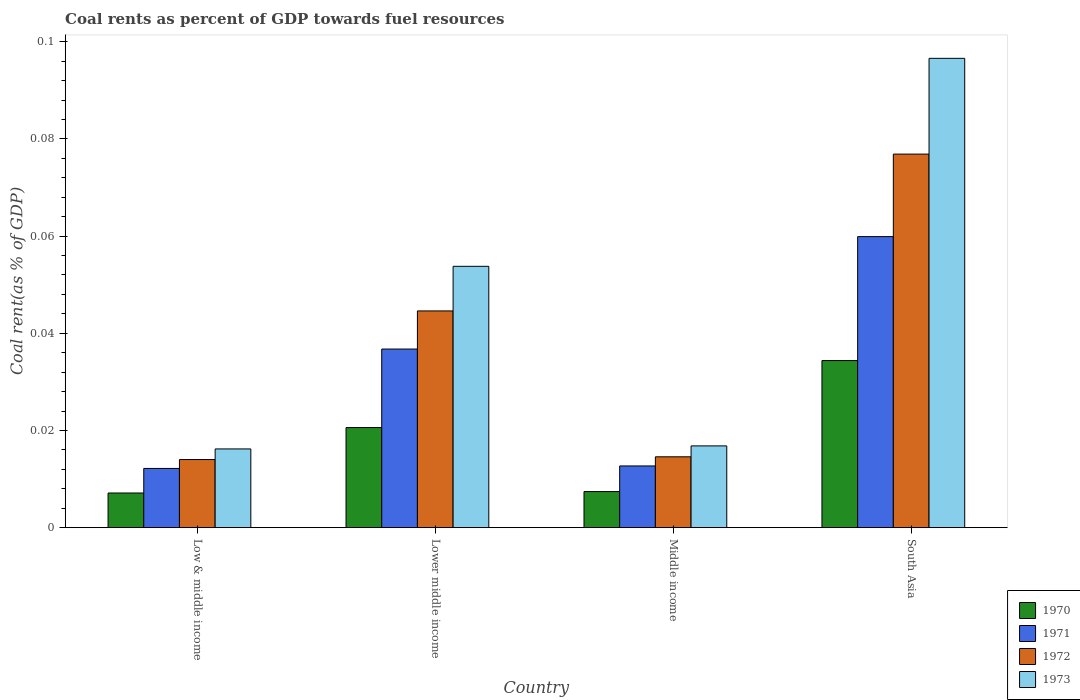What is the coal rent in 1971 in South Asia?
Provide a succinct answer. 0.06. Across all countries, what is the maximum coal rent in 1973?
Give a very brief answer. 0.1. Across all countries, what is the minimum coal rent in 1971?
Offer a terse response. 0.01. In which country was the coal rent in 1971 minimum?
Ensure brevity in your answer.  Low & middle income. What is the total coal rent in 1972 in the graph?
Your response must be concise. 0.15. What is the difference between the coal rent in 1972 in Low & middle income and that in South Asia?
Your response must be concise. -0.06. What is the difference between the coal rent in 1971 in South Asia and the coal rent in 1973 in Middle income?
Offer a terse response. 0.04. What is the average coal rent in 1973 per country?
Your answer should be compact. 0.05. What is the difference between the coal rent of/in 1972 and coal rent of/in 1970 in Middle income?
Provide a succinct answer. 0.01. In how many countries, is the coal rent in 1971 greater than 0.06 %?
Your answer should be very brief. 0. What is the ratio of the coal rent in 1972 in Lower middle income to that in South Asia?
Your response must be concise. 0.58. Is the coal rent in 1970 in Middle income less than that in South Asia?
Offer a terse response. Yes. What is the difference between the highest and the second highest coal rent in 1972?
Your response must be concise. 0.03. What is the difference between the highest and the lowest coal rent in 1972?
Offer a very short reply. 0.06. Is it the case that in every country, the sum of the coal rent in 1973 and coal rent in 1972 is greater than the coal rent in 1970?
Give a very brief answer. Yes. How many bars are there?
Keep it short and to the point. 16. How many countries are there in the graph?
Offer a terse response. 4. What is the difference between two consecutive major ticks on the Y-axis?
Your answer should be compact. 0.02. Are the values on the major ticks of Y-axis written in scientific E-notation?
Give a very brief answer. No. Does the graph contain any zero values?
Provide a succinct answer. No. Does the graph contain grids?
Provide a succinct answer. No. How many legend labels are there?
Your answer should be compact. 4. What is the title of the graph?
Your response must be concise. Coal rents as percent of GDP towards fuel resources. What is the label or title of the Y-axis?
Your response must be concise. Coal rent(as % of GDP). What is the Coal rent(as % of GDP) of 1970 in Low & middle income?
Offer a very short reply. 0.01. What is the Coal rent(as % of GDP) in 1971 in Low & middle income?
Provide a short and direct response. 0.01. What is the Coal rent(as % of GDP) of 1972 in Low & middle income?
Make the answer very short. 0.01. What is the Coal rent(as % of GDP) in 1973 in Low & middle income?
Offer a very short reply. 0.02. What is the Coal rent(as % of GDP) of 1970 in Lower middle income?
Offer a terse response. 0.02. What is the Coal rent(as % of GDP) in 1971 in Lower middle income?
Offer a terse response. 0.04. What is the Coal rent(as % of GDP) of 1972 in Lower middle income?
Offer a terse response. 0.04. What is the Coal rent(as % of GDP) of 1973 in Lower middle income?
Make the answer very short. 0.05. What is the Coal rent(as % of GDP) of 1970 in Middle income?
Keep it short and to the point. 0.01. What is the Coal rent(as % of GDP) of 1971 in Middle income?
Your answer should be compact. 0.01. What is the Coal rent(as % of GDP) of 1972 in Middle income?
Give a very brief answer. 0.01. What is the Coal rent(as % of GDP) of 1973 in Middle income?
Provide a succinct answer. 0.02. What is the Coal rent(as % of GDP) in 1970 in South Asia?
Provide a succinct answer. 0.03. What is the Coal rent(as % of GDP) in 1971 in South Asia?
Your answer should be very brief. 0.06. What is the Coal rent(as % of GDP) in 1972 in South Asia?
Offer a terse response. 0.08. What is the Coal rent(as % of GDP) in 1973 in South Asia?
Offer a terse response. 0.1. Across all countries, what is the maximum Coal rent(as % of GDP) of 1970?
Your response must be concise. 0.03. Across all countries, what is the maximum Coal rent(as % of GDP) of 1971?
Ensure brevity in your answer.  0.06. Across all countries, what is the maximum Coal rent(as % of GDP) in 1972?
Make the answer very short. 0.08. Across all countries, what is the maximum Coal rent(as % of GDP) of 1973?
Provide a succinct answer. 0.1. Across all countries, what is the minimum Coal rent(as % of GDP) of 1970?
Ensure brevity in your answer.  0.01. Across all countries, what is the minimum Coal rent(as % of GDP) of 1971?
Give a very brief answer. 0.01. Across all countries, what is the minimum Coal rent(as % of GDP) of 1972?
Offer a very short reply. 0.01. Across all countries, what is the minimum Coal rent(as % of GDP) of 1973?
Make the answer very short. 0.02. What is the total Coal rent(as % of GDP) in 1970 in the graph?
Give a very brief answer. 0.07. What is the total Coal rent(as % of GDP) in 1971 in the graph?
Offer a very short reply. 0.12. What is the total Coal rent(as % of GDP) of 1972 in the graph?
Your answer should be very brief. 0.15. What is the total Coal rent(as % of GDP) of 1973 in the graph?
Ensure brevity in your answer.  0.18. What is the difference between the Coal rent(as % of GDP) in 1970 in Low & middle income and that in Lower middle income?
Make the answer very short. -0.01. What is the difference between the Coal rent(as % of GDP) of 1971 in Low & middle income and that in Lower middle income?
Your answer should be compact. -0.02. What is the difference between the Coal rent(as % of GDP) of 1972 in Low & middle income and that in Lower middle income?
Your answer should be compact. -0.03. What is the difference between the Coal rent(as % of GDP) in 1973 in Low & middle income and that in Lower middle income?
Offer a terse response. -0.04. What is the difference between the Coal rent(as % of GDP) of 1970 in Low & middle income and that in Middle income?
Give a very brief answer. -0. What is the difference between the Coal rent(as % of GDP) of 1971 in Low & middle income and that in Middle income?
Your response must be concise. -0. What is the difference between the Coal rent(as % of GDP) of 1972 in Low & middle income and that in Middle income?
Provide a succinct answer. -0. What is the difference between the Coal rent(as % of GDP) of 1973 in Low & middle income and that in Middle income?
Your answer should be compact. -0. What is the difference between the Coal rent(as % of GDP) of 1970 in Low & middle income and that in South Asia?
Your answer should be compact. -0.03. What is the difference between the Coal rent(as % of GDP) of 1971 in Low & middle income and that in South Asia?
Offer a very short reply. -0.05. What is the difference between the Coal rent(as % of GDP) of 1972 in Low & middle income and that in South Asia?
Your answer should be very brief. -0.06. What is the difference between the Coal rent(as % of GDP) in 1973 in Low & middle income and that in South Asia?
Offer a very short reply. -0.08. What is the difference between the Coal rent(as % of GDP) in 1970 in Lower middle income and that in Middle income?
Your answer should be compact. 0.01. What is the difference between the Coal rent(as % of GDP) in 1971 in Lower middle income and that in Middle income?
Your answer should be compact. 0.02. What is the difference between the Coal rent(as % of GDP) in 1973 in Lower middle income and that in Middle income?
Your answer should be very brief. 0.04. What is the difference between the Coal rent(as % of GDP) in 1970 in Lower middle income and that in South Asia?
Your answer should be very brief. -0.01. What is the difference between the Coal rent(as % of GDP) in 1971 in Lower middle income and that in South Asia?
Ensure brevity in your answer.  -0.02. What is the difference between the Coal rent(as % of GDP) of 1972 in Lower middle income and that in South Asia?
Provide a short and direct response. -0.03. What is the difference between the Coal rent(as % of GDP) in 1973 in Lower middle income and that in South Asia?
Provide a short and direct response. -0.04. What is the difference between the Coal rent(as % of GDP) of 1970 in Middle income and that in South Asia?
Your answer should be very brief. -0.03. What is the difference between the Coal rent(as % of GDP) of 1971 in Middle income and that in South Asia?
Give a very brief answer. -0.05. What is the difference between the Coal rent(as % of GDP) in 1972 in Middle income and that in South Asia?
Your answer should be very brief. -0.06. What is the difference between the Coal rent(as % of GDP) in 1973 in Middle income and that in South Asia?
Your answer should be compact. -0.08. What is the difference between the Coal rent(as % of GDP) in 1970 in Low & middle income and the Coal rent(as % of GDP) in 1971 in Lower middle income?
Your response must be concise. -0.03. What is the difference between the Coal rent(as % of GDP) of 1970 in Low & middle income and the Coal rent(as % of GDP) of 1972 in Lower middle income?
Your answer should be compact. -0.04. What is the difference between the Coal rent(as % of GDP) in 1970 in Low & middle income and the Coal rent(as % of GDP) in 1973 in Lower middle income?
Make the answer very short. -0.05. What is the difference between the Coal rent(as % of GDP) of 1971 in Low & middle income and the Coal rent(as % of GDP) of 1972 in Lower middle income?
Keep it short and to the point. -0.03. What is the difference between the Coal rent(as % of GDP) of 1971 in Low & middle income and the Coal rent(as % of GDP) of 1973 in Lower middle income?
Offer a very short reply. -0.04. What is the difference between the Coal rent(as % of GDP) of 1972 in Low & middle income and the Coal rent(as % of GDP) of 1973 in Lower middle income?
Give a very brief answer. -0.04. What is the difference between the Coal rent(as % of GDP) of 1970 in Low & middle income and the Coal rent(as % of GDP) of 1971 in Middle income?
Make the answer very short. -0.01. What is the difference between the Coal rent(as % of GDP) in 1970 in Low & middle income and the Coal rent(as % of GDP) in 1972 in Middle income?
Your answer should be compact. -0.01. What is the difference between the Coal rent(as % of GDP) in 1970 in Low & middle income and the Coal rent(as % of GDP) in 1973 in Middle income?
Your response must be concise. -0.01. What is the difference between the Coal rent(as % of GDP) of 1971 in Low & middle income and the Coal rent(as % of GDP) of 1972 in Middle income?
Offer a terse response. -0. What is the difference between the Coal rent(as % of GDP) in 1971 in Low & middle income and the Coal rent(as % of GDP) in 1973 in Middle income?
Your answer should be very brief. -0. What is the difference between the Coal rent(as % of GDP) of 1972 in Low & middle income and the Coal rent(as % of GDP) of 1973 in Middle income?
Provide a short and direct response. -0. What is the difference between the Coal rent(as % of GDP) in 1970 in Low & middle income and the Coal rent(as % of GDP) in 1971 in South Asia?
Make the answer very short. -0.05. What is the difference between the Coal rent(as % of GDP) in 1970 in Low & middle income and the Coal rent(as % of GDP) in 1972 in South Asia?
Give a very brief answer. -0.07. What is the difference between the Coal rent(as % of GDP) of 1970 in Low & middle income and the Coal rent(as % of GDP) of 1973 in South Asia?
Provide a succinct answer. -0.09. What is the difference between the Coal rent(as % of GDP) in 1971 in Low & middle income and the Coal rent(as % of GDP) in 1972 in South Asia?
Give a very brief answer. -0.06. What is the difference between the Coal rent(as % of GDP) in 1971 in Low & middle income and the Coal rent(as % of GDP) in 1973 in South Asia?
Your answer should be compact. -0.08. What is the difference between the Coal rent(as % of GDP) in 1972 in Low & middle income and the Coal rent(as % of GDP) in 1973 in South Asia?
Provide a succinct answer. -0.08. What is the difference between the Coal rent(as % of GDP) of 1970 in Lower middle income and the Coal rent(as % of GDP) of 1971 in Middle income?
Provide a succinct answer. 0.01. What is the difference between the Coal rent(as % of GDP) of 1970 in Lower middle income and the Coal rent(as % of GDP) of 1972 in Middle income?
Your answer should be very brief. 0.01. What is the difference between the Coal rent(as % of GDP) in 1970 in Lower middle income and the Coal rent(as % of GDP) in 1973 in Middle income?
Provide a short and direct response. 0. What is the difference between the Coal rent(as % of GDP) in 1971 in Lower middle income and the Coal rent(as % of GDP) in 1972 in Middle income?
Your answer should be compact. 0.02. What is the difference between the Coal rent(as % of GDP) in 1971 in Lower middle income and the Coal rent(as % of GDP) in 1973 in Middle income?
Offer a very short reply. 0.02. What is the difference between the Coal rent(as % of GDP) in 1972 in Lower middle income and the Coal rent(as % of GDP) in 1973 in Middle income?
Give a very brief answer. 0.03. What is the difference between the Coal rent(as % of GDP) in 1970 in Lower middle income and the Coal rent(as % of GDP) in 1971 in South Asia?
Offer a terse response. -0.04. What is the difference between the Coal rent(as % of GDP) of 1970 in Lower middle income and the Coal rent(as % of GDP) of 1972 in South Asia?
Your answer should be compact. -0.06. What is the difference between the Coal rent(as % of GDP) in 1970 in Lower middle income and the Coal rent(as % of GDP) in 1973 in South Asia?
Your response must be concise. -0.08. What is the difference between the Coal rent(as % of GDP) of 1971 in Lower middle income and the Coal rent(as % of GDP) of 1972 in South Asia?
Offer a very short reply. -0.04. What is the difference between the Coal rent(as % of GDP) of 1971 in Lower middle income and the Coal rent(as % of GDP) of 1973 in South Asia?
Your response must be concise. -0.06. What is the difference between the Coal rent(as % of GDP) of 1972 in Lower middle income and the Coal rent(as % of GDP) of 1973 in South Asia?
Keep it short and to the point. -0.05. What is the difference between the Coal rent(as % of GDP) of 1970 in Middle income and the Coal rent(as % of GDP) of 1971 in South Asia?
Your response must be concise. -0.05. What is the difference between the Coal rent(as % of GDP) of 1970 in Middle income and the Coal rent(as % of GDP) of 1972 in South Asia?
Offer a terse response. -0.07. What is the difference between the Coal rent(as % of GDP) in 1970 in Middle income and the Coal rent(as % of GDP) in 1973 in South Asia?
Offer a terse response. -0.09. What is the difference between the Coal rent(as % of GDP) in 1971 in Middle income and the Coal rent(as % of GDP) in 1972 in South Asia?
Give a very brief answer. -0.06. What is the difference between the Coal rent(as % of GDP) of 1971 in Middle income and the Coal rent(as % of GDP) of 1973 in South Asia?
Ensure brevity in your answer.  -0.08. What is the difference between the Coal rent(as % of GDP) in 1972 in Middle income and the Coal rent(as % of GDP) in 1973 in South Asia?
Make the answer very short. -0.08. What is the average Coal rent(as % of GDP) in 1970 per country?
Your answer should be compact. 0.02. What is the average Coal rent(as % of GDP) in 1971 per country?
Your response must be concise. 0.03. What is the average Coal rent(as % of GDP) of 1972 per country?
Provide a succinct answer. 0.04. What is the average Coal rent(as % of GDP) of 1973 per country?
Your response must be concise. 0.05. What is the difference between the Coal rent(as % of GDP) of 1970 and Coal rent(as % of GDP) of 1971 in Low & middle income?
Provide a short and direct response. -0.01. What is the difference between the Coal rent(as % of GDP) of 1970 and Coal rent(as % of GDP) of 1972 in Low & middle income?
Offer a very short reply. -0.01. What is the difference between the Coal rent(as % of GDP) in 1970 and Coal rent(as % of GDP) in 1973 in Low & middle income?
Keep it short and to the point. -0.01. What is the difference between the Coal rent(as % of GDP) in 1971 and Coal rent(as % of GDP) in 1972 in Low & middle income?
Ensure brevity in your answer.  -0. What is the difference between the Coal rent(as % of GDP) of 1971 and Coal rent(as % of GDP) of 1973 in Low & middle income?
Offer a terse response. -0. What is the difference between the Coal rent(as % of GDP) in 1972 and Coal rent(as % of GDP) in 1973 in Low & middle income?
Keep it short and to the point. -0. What is the difference between the Coal rent(as % of GDP) of 1970 and Coal rent(as % of GDP) of 1971 in Lower middle income?
Provide a short and direct response. -0.02. What is the difference between the Coal rent(as % of GDP) of 1970 and Coal rent(as % of GDP) of 1972 in Lower middle income?
Give a very brief answer. -0.02. What is the difference between the Coal rent(as % of GDP) in 1970 and Coal rent(as % of GDP) in 1973 in Lower middle income?
Keep it short and to the point. -0.03. What is the difference between the Coal rent(as % of GDP) in 1971 and Coal rent(as % of GDP) in 1972 in Lower middle income?
Offer a terse response. -0.01. What is the difference between the Coal rent(as % of GDP) in 1971 and Coal rent(as % of GDP) in 1973 in Lower middle income?
Make the answer very short. -0.02. What is the difference between the Coal rent(as % of GDP) of 1972 and Coal rent(as % of GDP) of 1973 in Lower middle income?
Give a very brief answer. -0.01. What is the difference between the Coal rent(as % of GDP) of 1970 and Coal rent(as % of GDP) of 1971 in Middle income?
Keep it short and to the point. -0.01. What is the difference between the Coal rent(as % of GDP) in 1970 and Coal rent(as % of GDP) in 1972 in Middle income?
Offer a terse response. -0.01. What is the difference between the Coal rent(as % of GDP) in 1970 and Coal rent(as % of GDP) in 1973 in Middle income?
Your answer should be compact. -0.01. What is the difference between the Coal rent(as % of GDP) of 1971 and Coal rent(as % of GDP) of 1972 in Middle income?
Make the answer very short. -0. What is the difference between the Coal rent(as % of GDP) of 1971 and Coal rent(as % of GDP) of 1973 in Middle income?
Give a very brief answer. -0. What is the difference between the Coal rent(as % of GDP) of 1972 and Coal rent(as % of GDP) of 1973 in Middle income?
Ensure brevity in your answer.  -0. What is the difference between the Coal rent(as % of GDP) in 1970 and Coal rent(as % of GDP) in 1971 in South Asia?
Keep it short and to the point. -0.03. What is the difference between the Coal rent(as % of GDP) in 1970 and Coal rent(as % of GDP) in 1972 in South Asia?
Ensure brevity in your answer.  -0.04. What is the difference between the Coal rent(as % of GDP) of 1970 and Coal rent(as % of GDP) of 1973 in South Asia?
Offer a terse response. -0.06. What is the difference between the Coal rent(as % of GDP) in 1971 and Coal rent(as % of GDP) in 1972 in South Asia?
Ensure brevity in your answer.  -0.02. What is the difference between the Coal rent(as % of GDP) in 1971 and Coal rent(as % of GDP) in 1973 in South Asia?
Your answer should be very brief. -0.04. What is the difference between the Coal rent(as % of GDP) of 1972 and Coal rent(as % of GDP) of 1973 in South Asia?
Ensure brevity in your answer.  -0.02. What is the ratio of the Coal rent(as % of GDP) in 1970 in Low & middle income to that in Lower middle income?
Your answer should be compact. 0.35. What is the ratio of the Coal rent(as % of GDP) in 1971 in Low & middle income to that in Lower middle income?
Give a very brief answer. 0.33. What is the ratio of the Coal rent(as % of GDP) in 1972 in Low & middle income to that in Lower middle income?
Your response must be concise. 0.31. What is the ratio of the Coal rent(as % of GDP) in 1973 in Low & middle income to that in Lower middle income?
Ensure brevity in your answer.  0.3. What is the ratio of the Coal rent(as % of GDP) of 1970 in Low & middle income to that in Middle income?
Provide a succinct answer. 0.96. What is the ratio of the Coal rent(as % of GDP) in 1971 in Low & middle income to that in Middle income?
Make the answer very short. 0.96. What is the ratio of the Coal rent(as % of GDP) of 1972 in Low & middle income to that in Middle income?
Offer a terse response. 0.96. What is the ratio of the Coal rent(as % of GDP) of 1973 in Low & middle income to that in Middle income?
Offer a terse response. 0.96. What is the ratio of the Coal rent(as % of GDP) in 1970 in Low & middle income to that in South Asia?
Keep it short and to the point. 0.21. What is the ratio of the Coal rent(as % of GDP) of 1971 in Low & middle income to that in South Asia?
Your response must be concise. 0.2. What is the ratio of the Coal rent(as % of GDP) in 1972 in Low & middle income to that in South Asia?
Offer a terse response. 0.18. What is the ratio of the Coal rent(as % of GDP) in 1973 in Low & middle income to that in South Asia?
Offer a very short reply. 0.17. What is the ratio of the Coal rent(as % of GDP) of 1970 in Lower middle income to that in Middle income?
Provide a short and direct response. 2.78. What is the ratio of the Coal rent(as % of GDP) in 1971 in Lower middle income to that in Middle income?
Keep it short and to the point. 2.9. What is the ratio of the Coal rent(as % of GDP) in 1972 in Lower middle income to that in Middle income?
Your answer should be compact. 3.06. What is the ratio of the Coal rent(as % of GDP) in 1973 in Lower middle income to that in Middle income?
Keep it short and to the point. 3.2. What is the ratio of the Coal rent(as % of GDP) in 1970 in Lower middle income to that in South Asia?
Provide a succinct answer. 0.6. What is the ratio of the Coal rent(as % of GDP) in 1971 in Lower middle income to that in South Asia?
Your response must be concise. 0.61. What is the ratio of the Coal rent(as % of GDP) in 1972 in Lower middle income to that in South Asia?
Provide a succinct answer. 0.58. What is the ratio of the Coal rent(as % of GDP) of 1973 in Lower middle income to that in South Asia?
Give a very brief answer. 0.56. What is the ratio of the Coal rent(as % of GDP) in 1970 in Middle income to that in South Asia?
Provide a short and direct response. 0.22. What is the ratio of the Coal rent(as % of GDP) of 1971 in Middle income to that in South Asia?
Provide a short and direct response. 0.21. What is the ratio of the Coal rent(as % of GDP) of 1972 in Middle income to that in South Asia?
Offer a terse response. 0.19. What is the ratio of the Coal rent(as % of GDP) in 1973 in Middle income to that in South Asia?
Keep it short and to the point. 0.17. What is the difference between the highest and the second highest Coal rent(as % of GDP) in 1970?
Offer a very short reply. 0.01. What is the difference between the highest and the second highest Coal rent(as % of GDP) in 1971?
Offer a terse response. 0.02. What is the difference between the highest and the second highest Coal rent(as % of GDP) of 1972?
Offer a very short reply. 0.03. What is the difference between the highest and the second highest Coal rent(as % of GDP) of 1973?
Provide a succinct answer. 0.04. What is the difference between the highest and the lowest Coal rent(as % of GDP) in 1970?
Ensure brevity in your answer.  0.03. What is the difference between the highest and the lowest Coal rent(as % of GDP) in 1971?
Your response must be concise. 0.05. What is the difference between the highest and the lowest Coal rent(as % of GDP) of 1972?
Your response must be concise. 0.06. What is the difference between the highest and the lowest Coal rent(as % of GDP) in 1973?
Your answer should be compact. 0.08. 